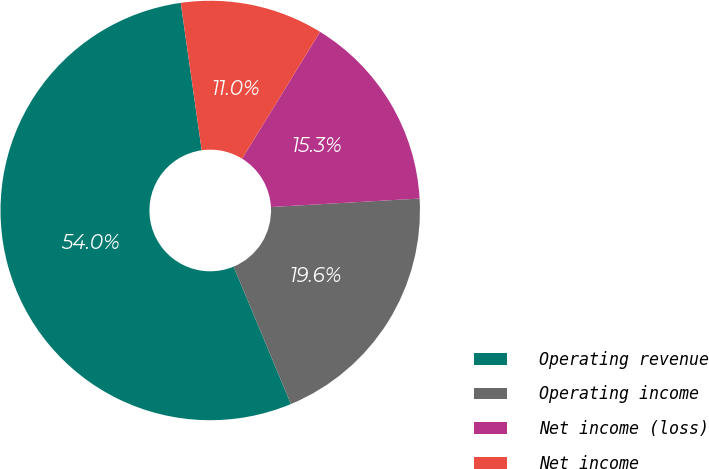Convert chart. <chart><loc_0><loc_0><loc_500><loc_500><pie_chart><fcel>Operating revenue<fcel>Operating income<fcel>Net income (loss)<fcel>Net income<nl><fcel>54.04%<fcel>19.62%<fcel>15.32%<fcel>11.02%<nl></chart> 